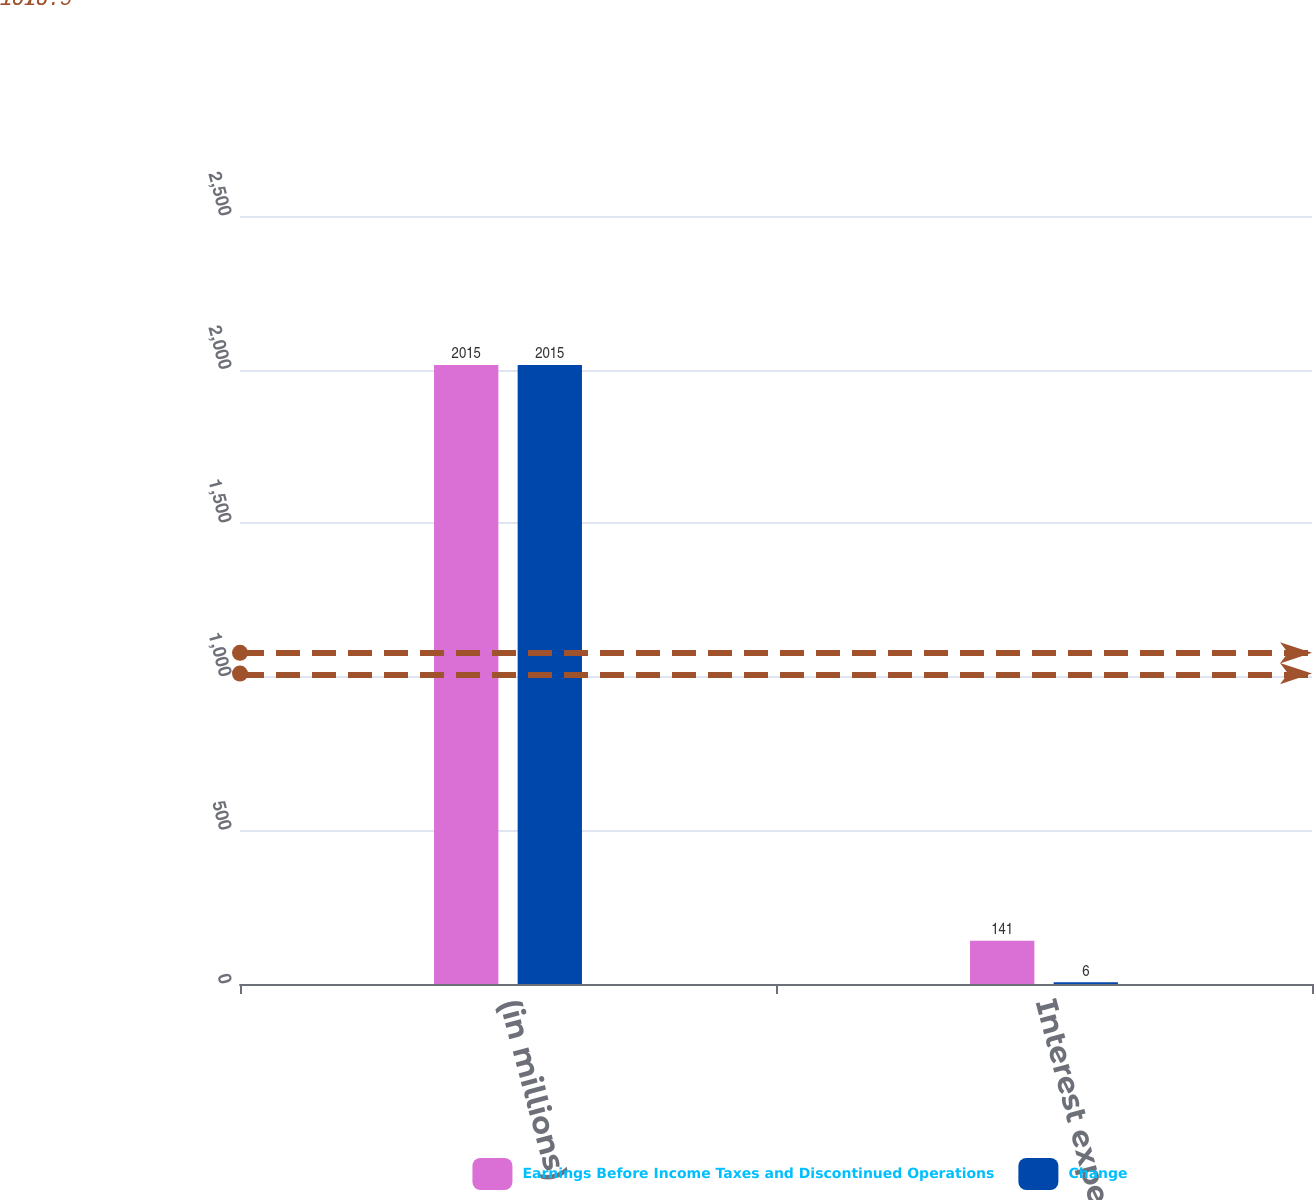Convert chart to OTSL. <chart><loc_0><loc_0><loc_500><loc_500><stacked_bar_chart><ecel><fcel>(in millions)<fcel>Interest expense net<nl><fcel>Earnings Before Income Taxes and Discontinued Operations<fcel>2015<fcel>141<nl><fcel>Change<fcel>2015<fcel>6<nl></chart> 